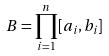<formula> <loc_0><loc_0><loc_500><loc_500>B = \prod _ { i = 1 } ^ { n } [ a _ { i } , b _ { i } ]</formula> 